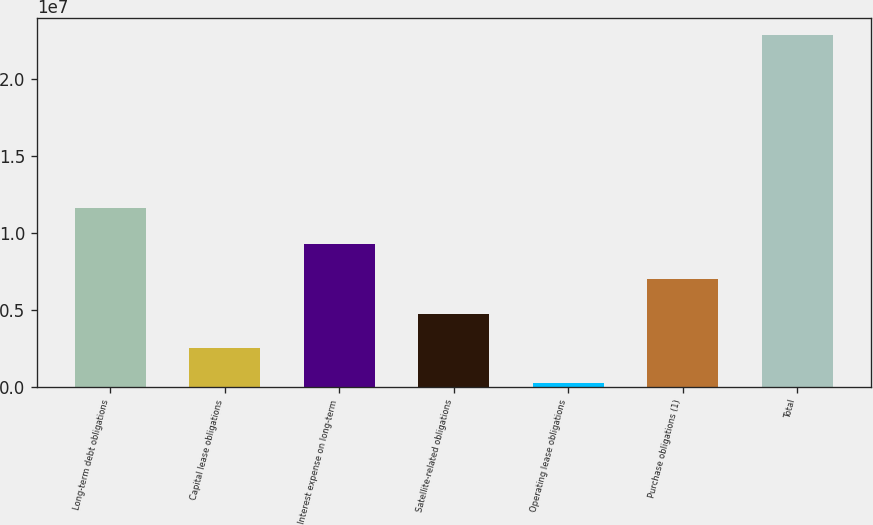Convert chart. <chart><loc_0><loc_0><loc_500><loc_500><bar_chart><fcel>Long-term debt obligations<fcel>Capital lease obligations<fcel>Interest expense on long-term<fcel>Satellite-related obligations<fcel>Operating lease obligations<fcel>Purchase obligations (1)<fcel>Total<nl><fcel>1.1639e+07<fcel>2.50308e+06<fcel>9.27543e+06<fcel>4.76053e+06<fcel>245630<fcel>7.01798e+06<fcel>2.28201e+07<nl></chart> 